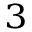<formula> <loc_0><loc_0><loc_500><loc_500>_ { 3 }</formula> 